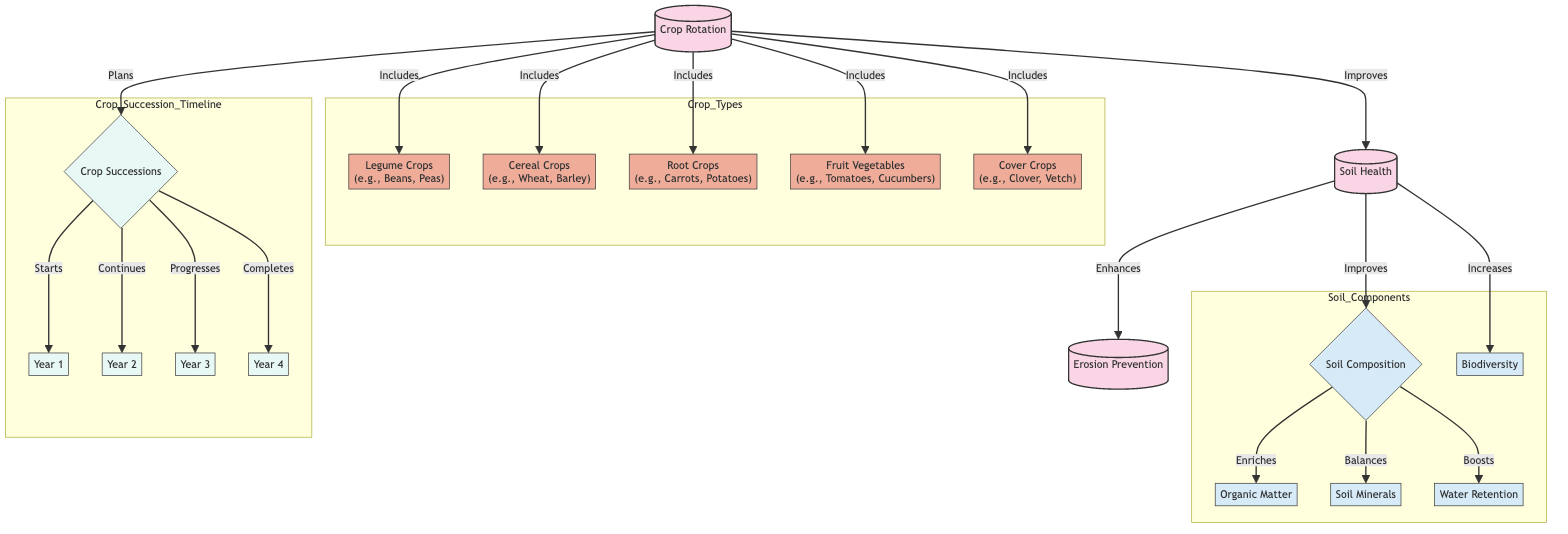What are the types of crops included in crop rotation? The diagram lists five types of crops under the crop rotation section: legume crops, cereal crops, root crops, fruit vegetables, and cover crops. These are directly connected to the crop rotation node.
Answer: legume crops, cereal crops, root crops, fruit vegetables, cover crops How many years are represented in the crop succession timeline? The crop succession section contains four distinct years, each represented as a separate node (Year 1, Year 2, Year 3, Year 4). These nodes are connected to the crop successions node, indicating progression through the years.
Answer: 4 What effect does soil health have on erosion prevention? The diagram shows a direct relationship where soil health enhances erosion prevention. This connection is marked by an arrow indicating the influence of soil health on preventing erosion.
Answer: Enhances What aspect of soil composition does crop rotation improve? Crop rotation has a direct effect on improving several elements of soil composition. Specifically, it enriches organic matter, balances soil minerals, and boosts water retention, all indicated in the diagram as effects of improved soil composition.
Answer: organic matter, soil minerals, water retention What role do cover crops play in crop rotation? The diagram indicates that cover crops are included in the crop rotation practices, contributing positively to soil health and subsequent benefits such as erosion prevention. The arrow signifies that cover crops are part of the holistic crop rotation strategy.
Answer: Included in crop rotation How does improving soil health contribute to biodiversity? The connection shown in the diagram indicates that improved soil health increases biodiversity. This relationship points out how healthier soils create a more favorable environment for a diverse array of organisms.
Answer: Increases What is the first year of the crop succession timeline? According to the diagram, the crop succession timeline begins with Year 1. This is the initial step signifying the start of the crop rotation plan.
Answer: Year 1 What components are influenced by soil composition? The diagram outlines three key aspects influenced by soil composition: organic matter, soil minerals, and water retention. Each of these aspects follows from the improvement of soil composition resulting from effective crop rotation practices.
Answer: organic matter, soil minerals, water retention How does crop rotation relate to soil health? The diagram illustrates that crop rotation improves soil health, establishing it as a primary method for enhancing the quality and condition of the soil through strategic planting methods. This relationship highlights the significance of rotation practices in sustainable agriculture.
Answer: Improves 